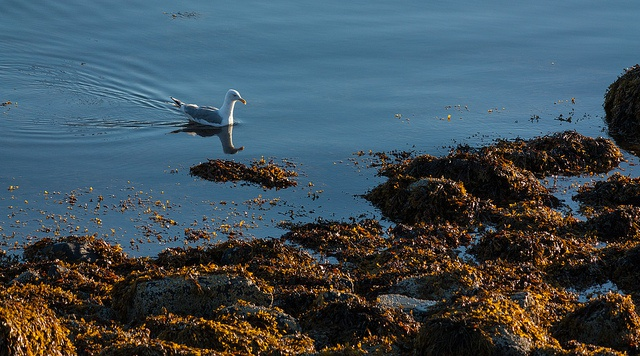Describe the objects in this image and their specific colors. I can see a bird in gray, darkblue, blue, and black tones in this image. 